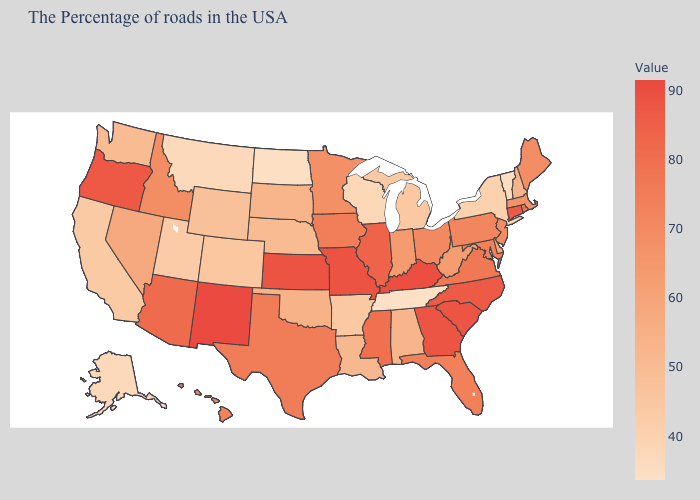Does Pennsylvania have the highest value in the USA?
Keep it brief. No. Among the states that border Connecticut , which have the lowest value?
Quick response, please. New York. Is the legend a continuous bar?
Give a very brief answer. Yes. Which states hav the highest value in the Northeast?
Be succinct. Connecticut. Does Alaska have the highest value in the USA?
Write a very short answer. No. Among the states that border Maryland , does Delaware have the lowest value?
Concise answer only. Yes. Which states have the highest value in the USA?
Write a very short answer. New Mexico. Does the map have missing data?
Write a very short answer. No. 